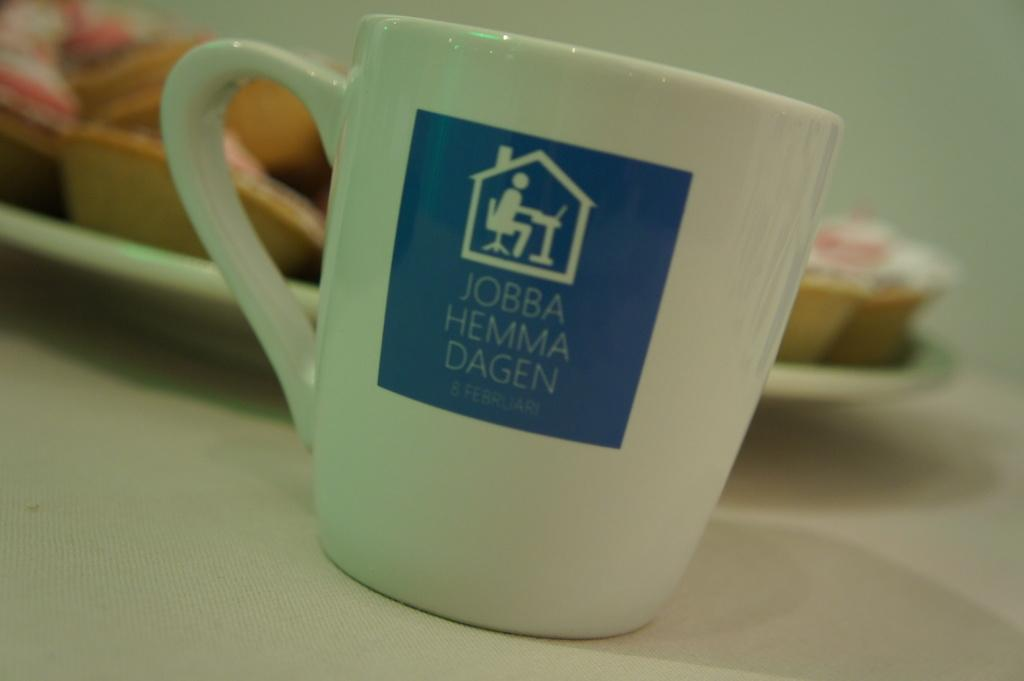<image>
Give a short and clear explanation of the subsequent image. a white mug with a blue square on it that says jobba hemma dagen 